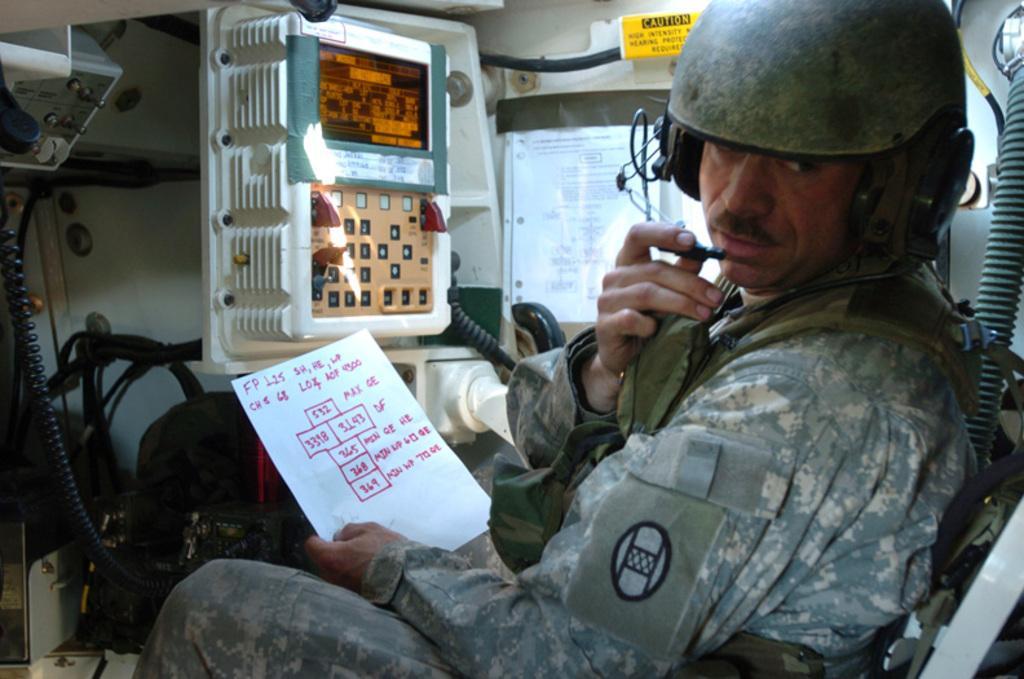How would you summarize this image in a sentence or two? In this image, we can see a person sitting and holding papers. In the background, we can see electrical equipment. 